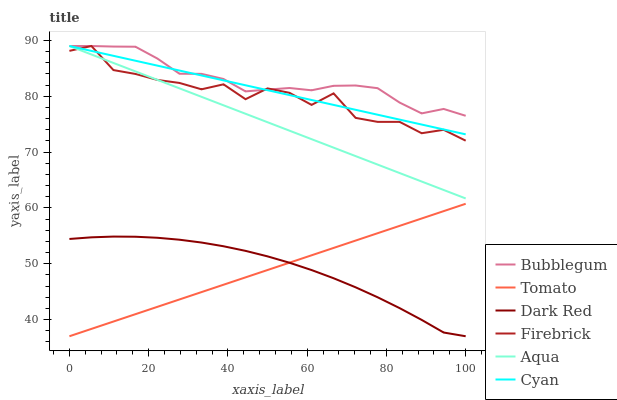Does Tomato have the minimum area under the curve?
Answer yes or no. Yes. Does Bubblegum have the maximum area under the curve?
Answer yes or no. Yes. Does Dark Red have the minimum area under the curve?
Answer yes or no. No. Does Dark Red have the maximum area under the curve?
Answer yes or no. No. Is Tomato the smoothest?
Answer yes or no. Yes. Is Firebrick the roughest?
Answer yes or no. Yes. Is Dark Red the smoothest?
Answer yes or no. No. Is Dark Red the roughest?
Answer yes or no. No. Does Tomato have the lowest value?
Answer yes or no. Yes. Does Firebrick have the lowest value?
Answer yes or no. No. Does Cyan have the highest value?
Answer yes or no. Yes. Does Dark Red have the highest value?
Answer yes or no. No. Is Tomato less than Firebrick?
Answer yes or no. Yes. Is Cyan greater than Tomato?
Answer yes or no. Yes. Does Bubblegum intersect Firebrick?
Answer yes or no. Yes. Is Bubblegum less than Firebrick?
Answer yes or no. No. Is Bubblegum greater than Firebrick?
Answer yes or no. No. Does Tomato intersect Firebrick?
Answer yes or no. No. 